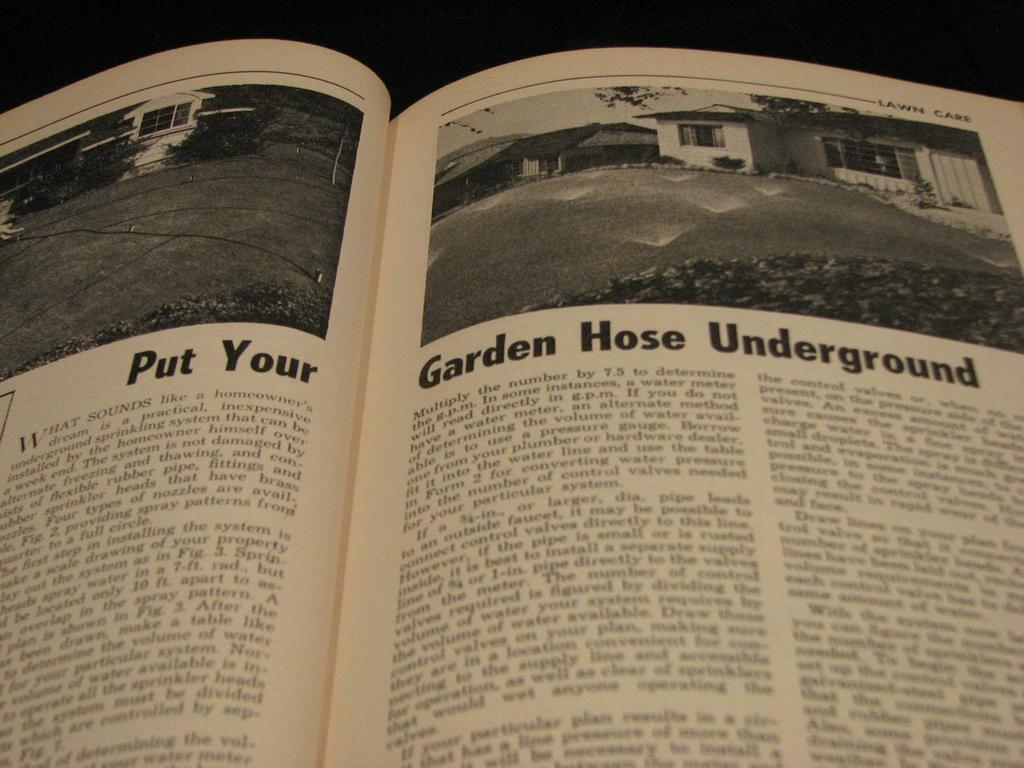<image>
Relay a brief, clear account of the picture shown. A book is open to a page that says Put Your Garden Hose Underground. 